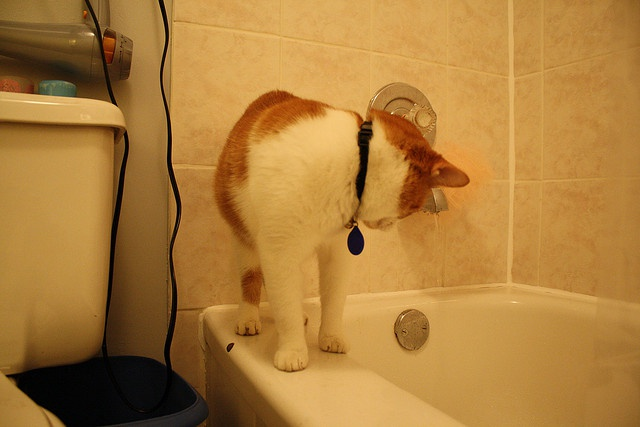Describe the objects in this image and their specific colors. I can see cat in olive, orange, and red tones, toilet in olive and tan tones, and hair drier in olive, maroon, and black tones in this image. 